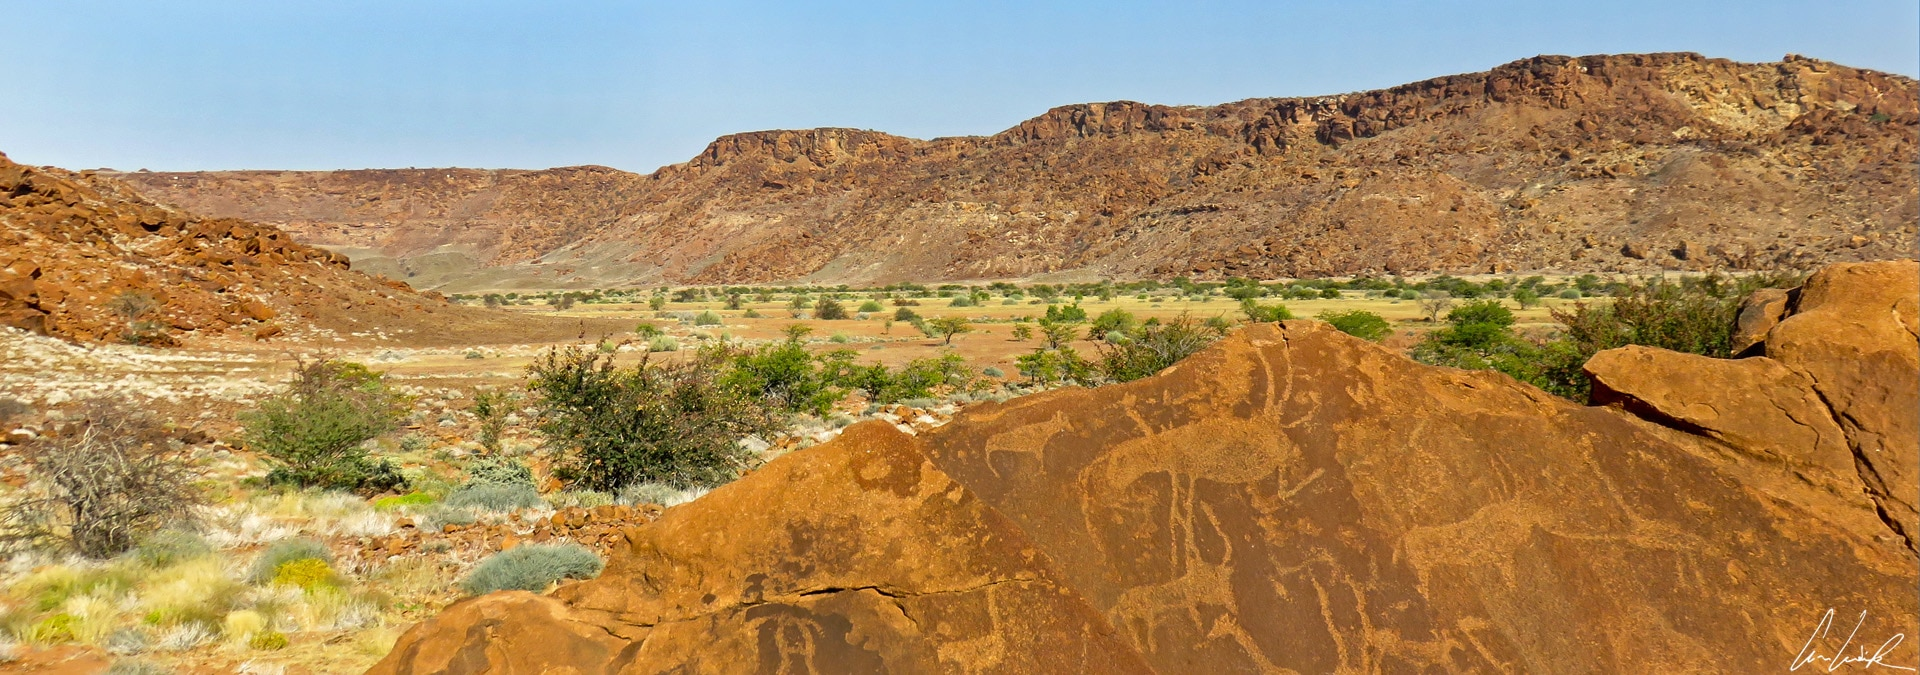How might the landscape change in future centuries? Over the next few centuries, the Twyfelfontein landscape may undergo significant transformations due to climate change and natural erosion. Wind and occasional rains will continue to shape the rocks, possibly wearing down some of the engravings while revealing others hidden beneath the surface. Vegetation patterns could shift as precipitation levels fluctuate, potentially leading to either desertification or the introduction of new plant species. Human influence might also play a role; future generations could establish protected areas to preserve the site's heritage or develop new ways to safeguard the engravings through advanced conservation techniques. Regardless of the changes, Twyfelfontein will likely remain a place imbued with historical and cultural significance, reflecting both natural and human histories intertwined. 